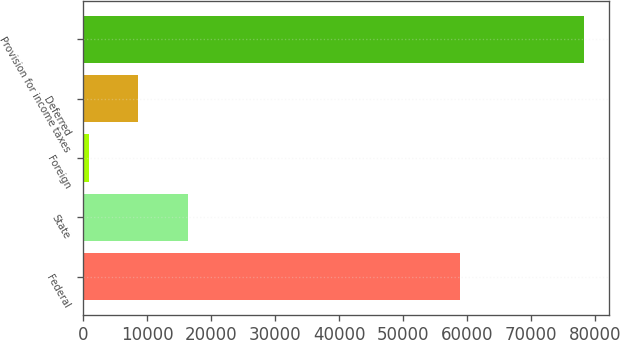Convert chart. <chart><loc_0><loc_0><loc_500><loc_500><bar_chart><fcel>Federal<fcel>State<fcel>Foreign<fcel>Deferred<fcel>Provision for income taxes<nl><fcel>58854<fcel>16296<fcel>825<fcel>8560.5<fcel>78180<nl></chart> 